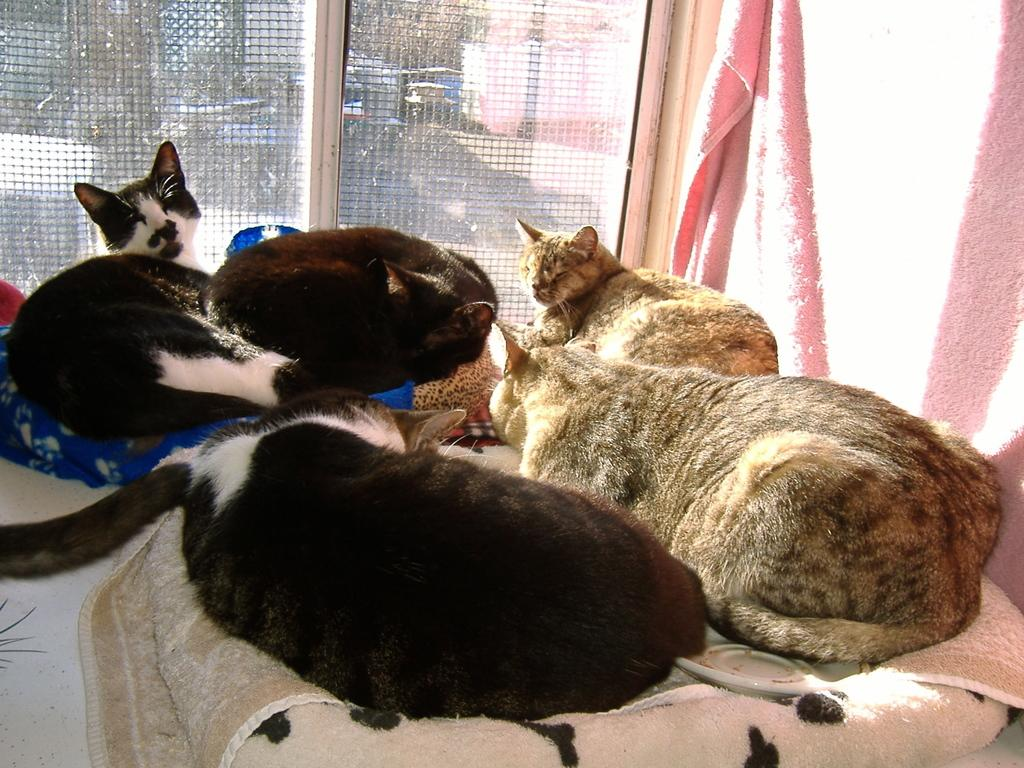What type of animals are in the image? There are cats in the image. What are the cats resting on in the image? The cats are on blankets. What type of wax can be seen melting in the image? There is no wax present in the image. What type of humor can be seen in the image? There is no specific type of humor depicted in the image; it simply features cats on blankets. What is the relationship between the cats and the person who took the image? The provided facts do not give any information about the person who took the image or their relationship with the cats. 